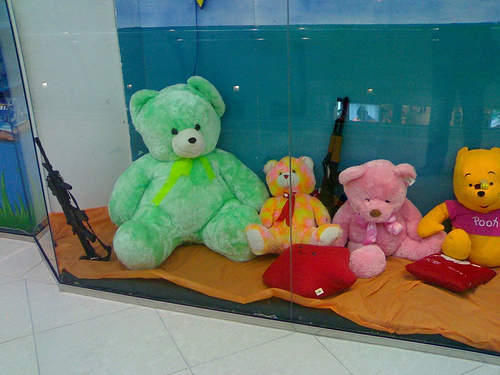Read all the text in this image. Pooh 